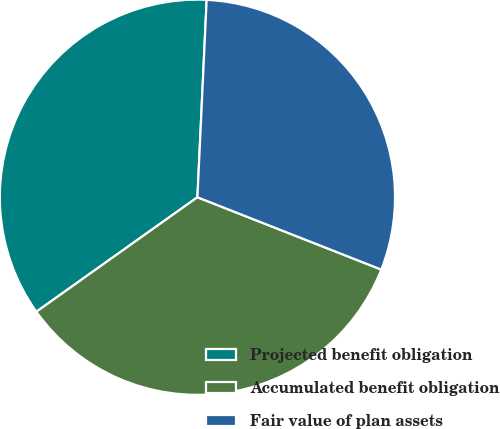Convert chart to OTSL. <chart><loc_0><loc_0><loc_500><loc_500><pie_chart><fcel>Projected benefit obligation<fcel>Accumulated benefit obligation<fcel>Fair value of plan assets<nl><fcel>35.58%<fcel>34.2%<fcel>30.22%<nl></chart> 